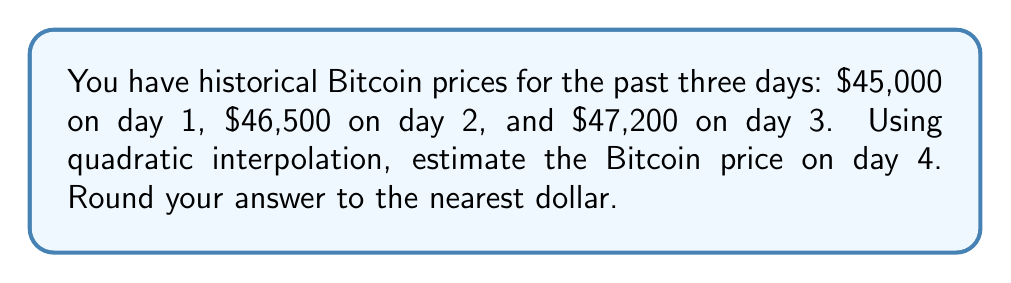What is the answer to this math problem? Let's approach this step-by-step using quadratic interpolation:

1) We'll use the quadratic polynomial $f(x) = ax^2 + bx + c$ where $x$ represents the day number.

2) We have three data points:
   $f(1) = 45000$
   $f(2) = 46500$
   $f(3) = 47200$

3) Substituting these into our quadratic equation:
   $45000 = a(1)^2 + b(1) + c$
   $46500 = a(2)^2 + b(2) + c$
   $47200 = a(3)^2 + b(3) + c$

4) Simplifying:
   $45000 = a + b + c$     (Equation 1)
   $46500 = 4a + 2b + c$   (Equation 2)
   $47200 = 9a + 3b + c$   (Equation 3)

5) Subtracting Equation 1 from Equation 2:
   $1500 = 3a + b$         (Equation 4)

6) Subtracting Equation 2 from Equation 3:
   $700 = 5a + b$          (Equation 5)

7) Subtracting Equation 4 from Equation 5:
   $-800 = 2a$
   $a = -400$

8) Substituting $a = -400$ into Equation 4:
   $1500 = 3(-400) + b$
   $1500 = -1200 + b$
   $b = 2700$

9) Substituting $a = -400$ and $b = 2700$ into Equation 1:
   $45000 = -400 + 2700 + c$
   $c = 42700$

10) Our quadratic function is thus:
    $f(x) = -400x^2 + 2700x + 42700$

11) To estimate the price on day 4, we calculate $f(4)$:
    $f(4) = -400(4)^2 + 2700(4) + 42700$
    $f(4) = -6400 + 10800 + 42700$
    $f(4) = 47100$

Therefore, the estimated Bitcoin price on day 4 is $47,100.
Answer: $47,100 